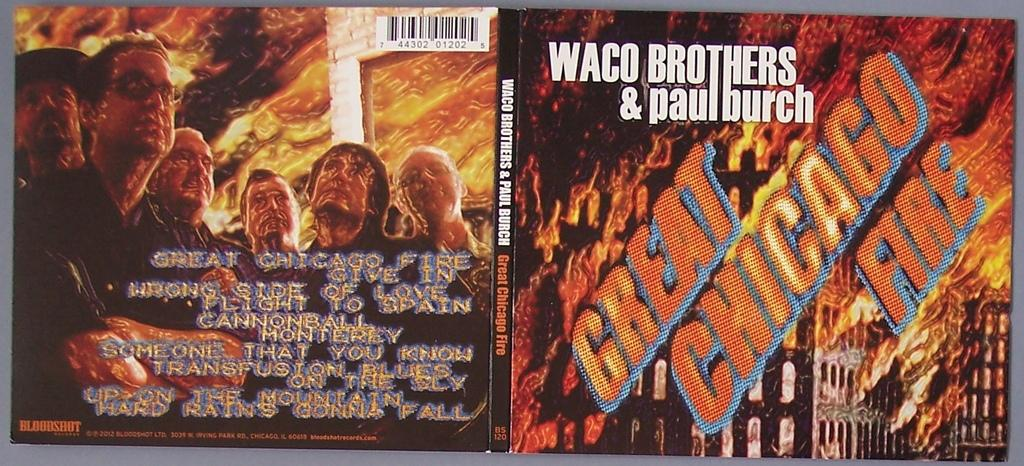<image>
Provide a brief description of the given image. A CD, entitled Great Chicago Fire, is by Waco Brothers and Paul Burch. 